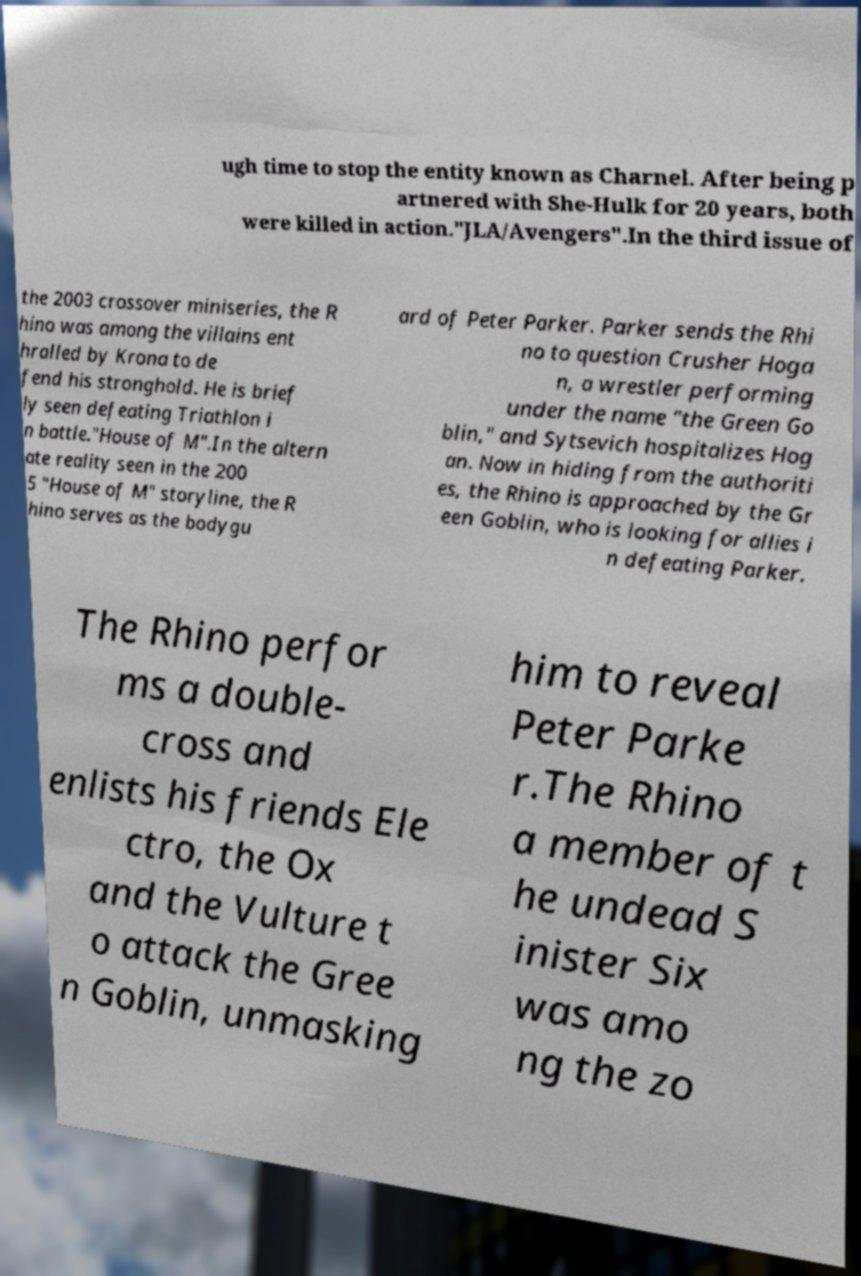Please identify and transcribe the text found in this image. ugh time to stop the entity known as Charnel. After being p artnered with She-Hulk for 20 years, both were killed in action."JLA/Avengers".In the third issue of the 2003 crossover miniseries, the R hino was among the villains ent hralled by Krona to de fend his stronghold. He is brief ly seen defeating Triathlon i n battle."House of M".In the altern ate reality seen in the 200 5 "House of M" storyline, the R hino serves as the bodygu ard of Peter Parker. Parker sends the Rhi no to question Crusher Hoga n, a wrestler performing under the name "the Green Go blin," and Sytsevich hospitalizes Hog an. Now in hiding from the authoriti es, the Rhino is approached by the Gr een Goblin, who is looking for allies i n defeating Parker. The Rhino perfor ms a double- cross and enlists his friends Ele ctro, the Ox and the Vulture t o attack the Gree n Goblin, unmasking him to reveal Peter Parke r.The Rhino a member of t he undead S inister Six was amo ng the zo 